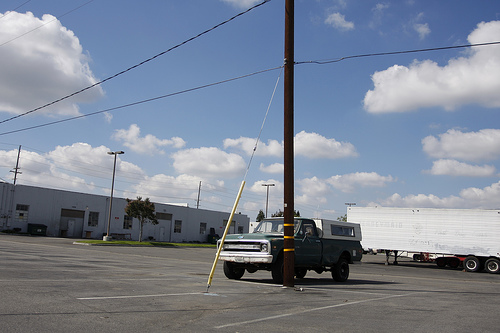<image>
Is there a cloud behind the truck? No. The cloud is not behind the truck. From this viewpoint, the cloud appears to be positioned elsewhere in the scene. Where is the truck in relation to the poll? Is it in front of the poll? No. The truck is not in front of the poll. The spatial positioning shows a different relationship between these objects. 